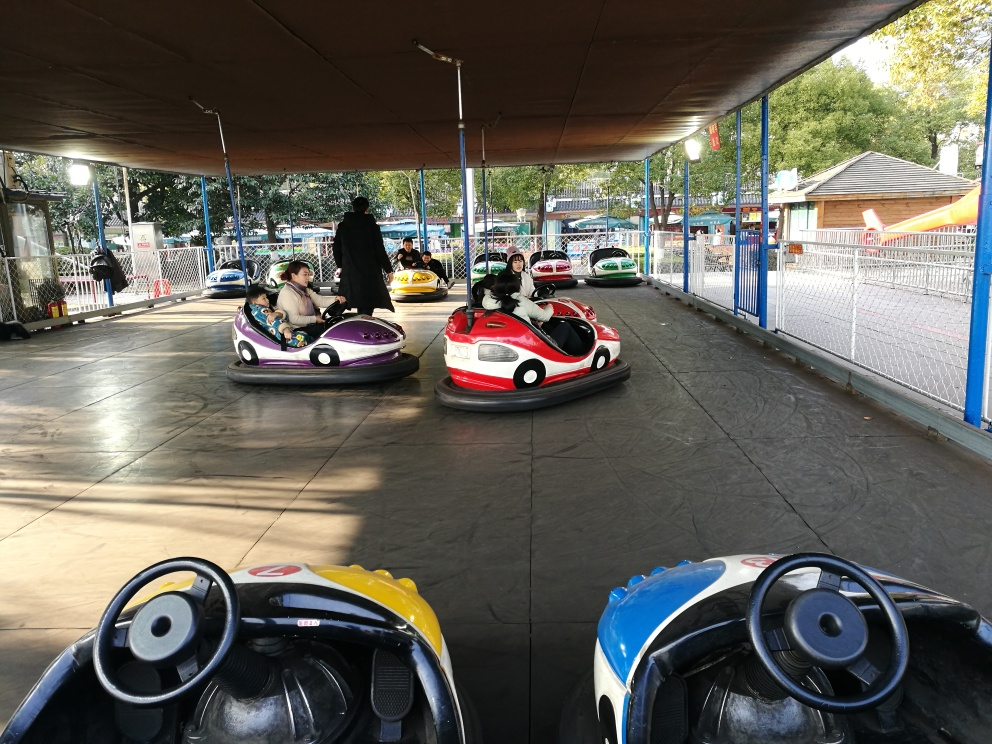What emotions do the people in the image seem to be experiencing? The individuals in the image appear to be experiencing a sense of enjoyment and relaxation. The driver in the closest car has a gentle focus on navigating the vehicle, while the passengers in the car further away seem to be looking around with interest, possibly taking in the sights and sounds of the amusement park or waiting for the ride to start. 